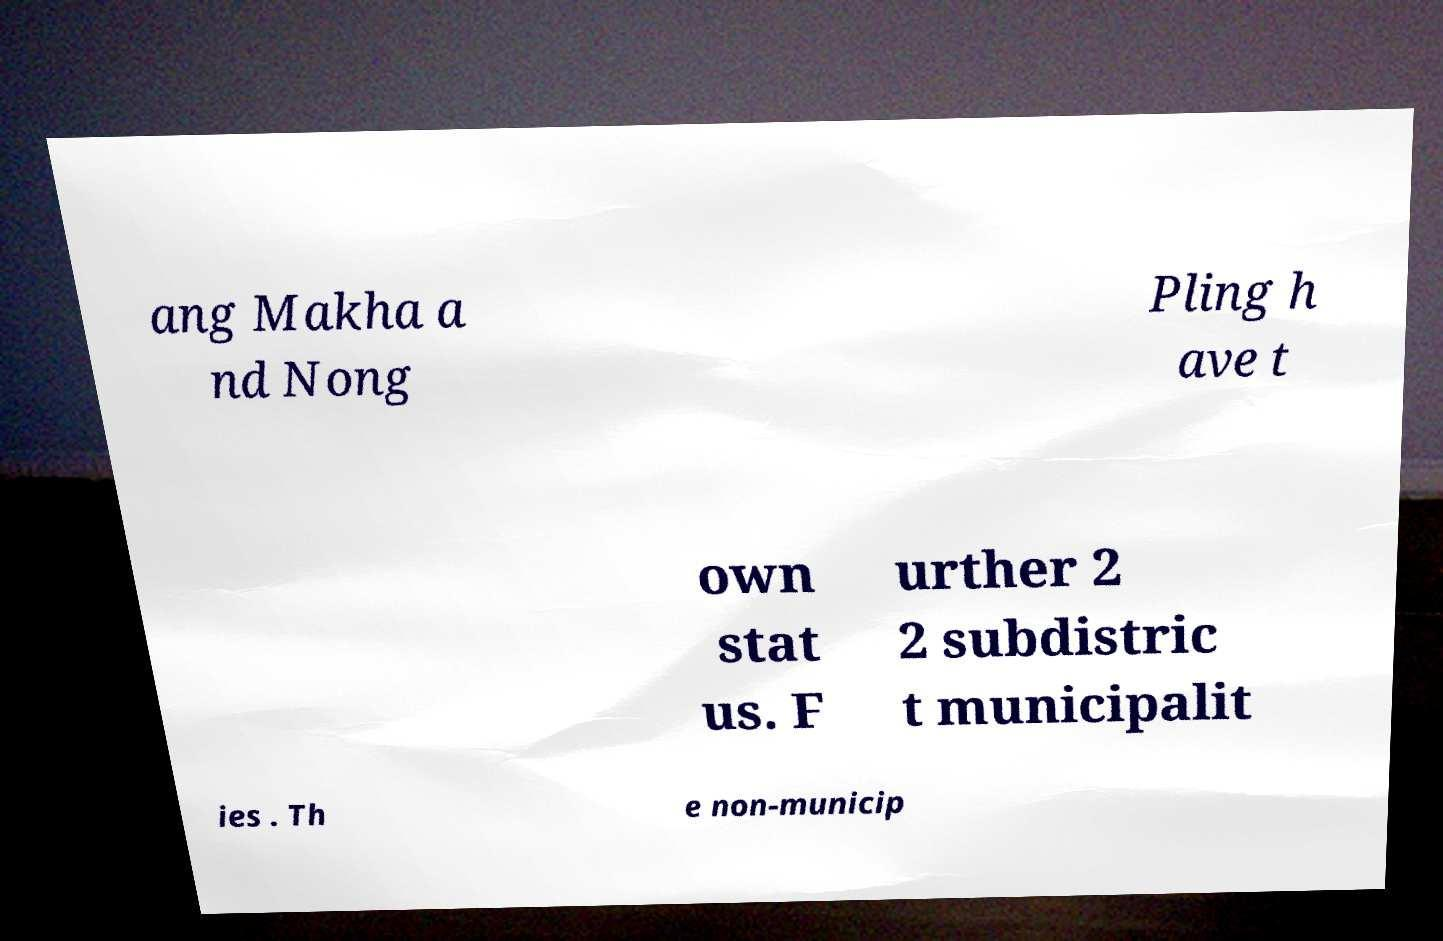I need the written content from this picture converted into text. Can you do that? ang Makha a nd Nong Pling h ave t own stat us. F urther 2 2 subdistric t municipalit ies . Th e non-municip 